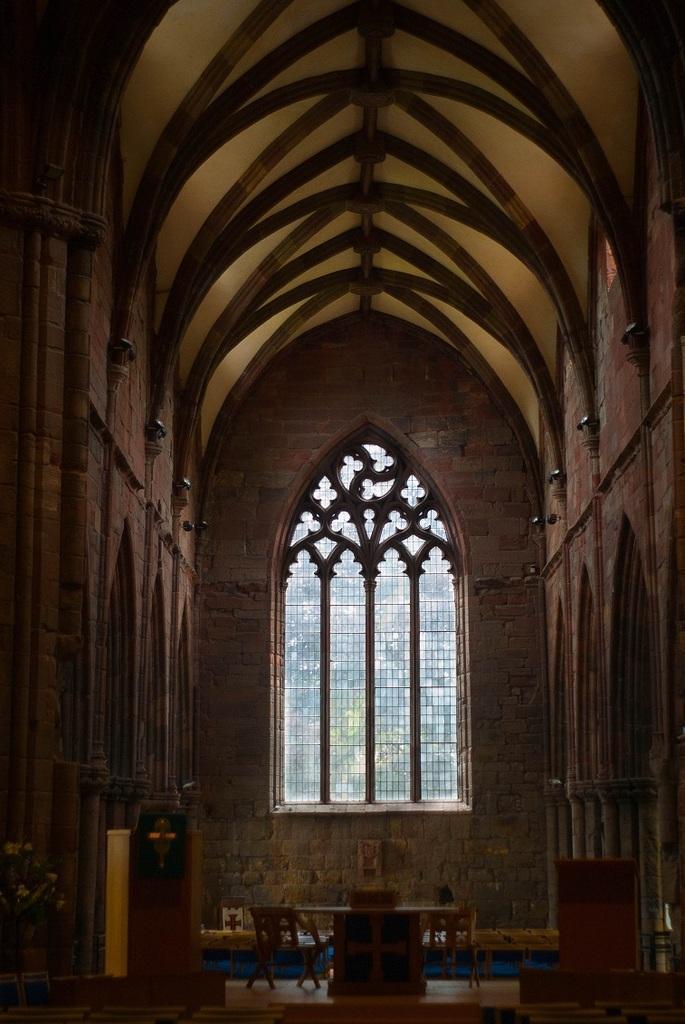Please provide a concise description of this image. In this image in the center there is a window, and there is a table and some boxes. At the bottom of the image there is floor and some objects, and on the right side and left side there is a wall. At the top there is ceiling and some poles. 